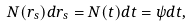Convert formula to latex. <formula><loc_0><loc_0><loc_500><loc_500>N ( r _ { s } ) d r _ { s } = N ( t ) d t = \psi d t ,</formula> 